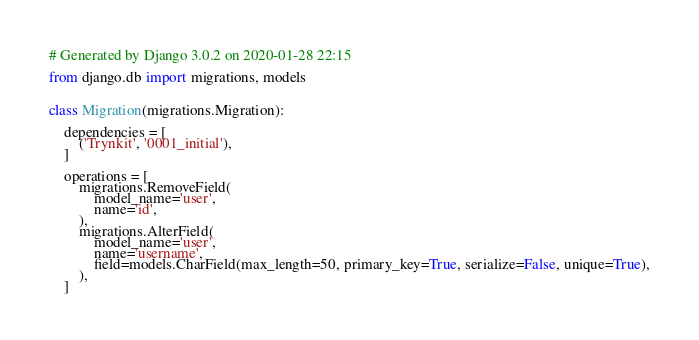Convert code to text. <code><loc_0><loc_0><loc_500><loc_500><_Python_># Generated by Django 3.0.2 on 2020-01-28 22:15

from django.db import migrations, models


class Migration(migrations.Migration):

    dependencies = [
        ('Trynkit', '0001_initial'),
    ]

    operations = [
        migrations.RemoveField(
            model_name='user',
            name='id',
        ),
        migrations.AlterField(
            model_name='user',
            name='username',
            field=models.CharField(max_length=50, primary_key=True, serialize=False, unique=True),
        ),
    ]
</code> 